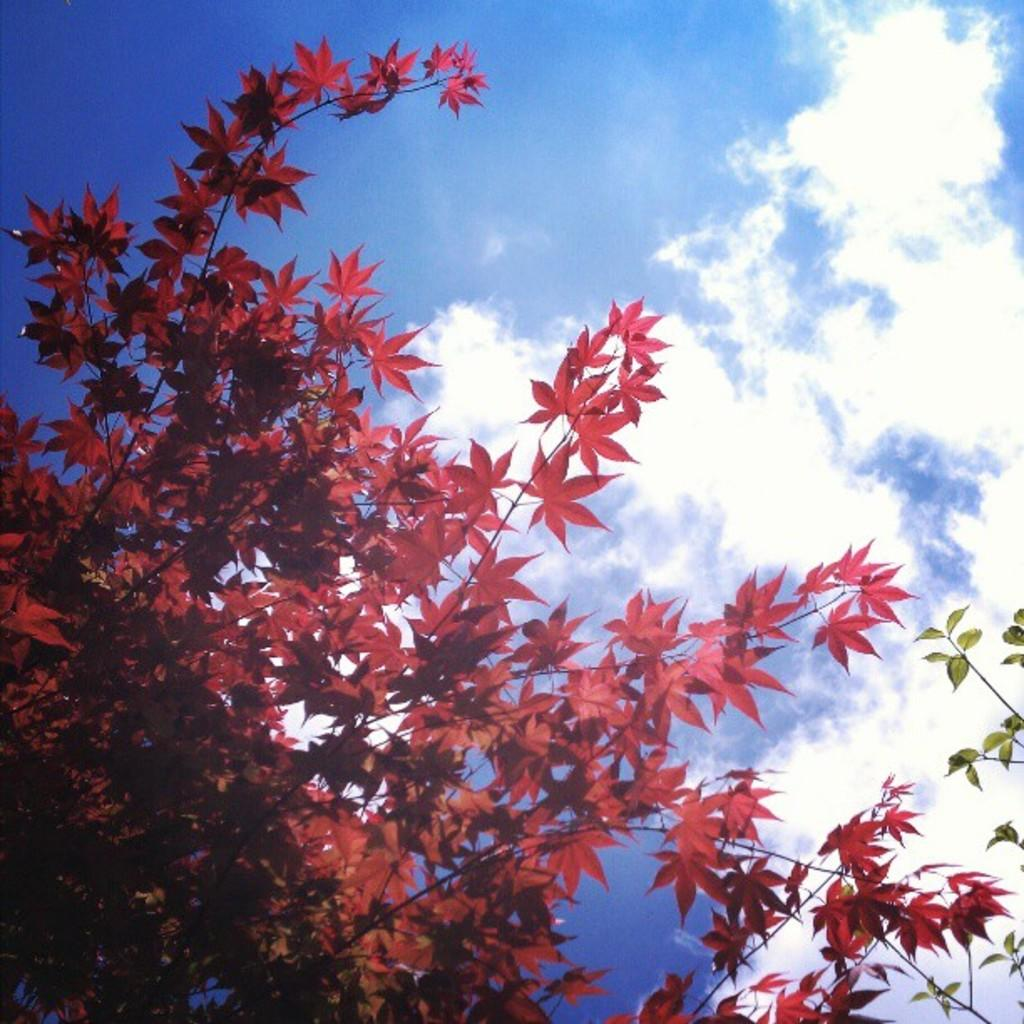What colors of leaves can be seen in the image? There are red and green leaves in the image. How are the leaves attached to the plant? The leaves are on stems in the image. What is visible in the background of the image? The sky is visible in the image. What colors can be seen in the sky? The sky has a white and blue color in the image. What type of industry can be seen in the image? There is no industry present in the image; it features leaves on stems with a sky background. Can you tell me how many coaches are visible in the image? There are no coaches present in the image; it features leaves on stems with a sky background. 